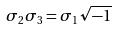Convert formula to latex. <formula><loc_0><loc_0><loc_500><loc_500>\sigma _ { 2 } \sigma _ { 3 } = \sigma _ { 1 } \sqrt { - 1 }</formula> 